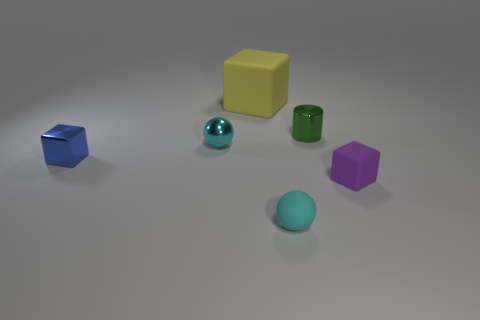What number of small purple blocks are behind the cube that is on the left side of the yellow thing?
Ensure brevity in your answer.  0. Is the number of spheres behind the small blue thing less than the number of blue things?
Your response must be concise. No. Is there a purple rubber object to the left of the small cube to the right of the ball in front of the tiny blue cube?
Offer a very short reply. No. Does the tiny green cylinder have the same material as the sphere on the left side of the big yellow matte cube?
Give a very brief answer. Yes. What is the color of the cylinder behind the purple rubber cube that is on the right side of the big yellow matte object?
Your answer should be very brief. Green. Is there a tiny rubber cube that has the same color as the metallic block?
Your answer should be very brief. No. How big is the matte block that is right of the cyan sphere that is in front of the tiny shiny object that is in front of the tiny cyan metal thing?
Your answer should be compact. Small. Is the shape of the big rubber thing the same as the cyan thing that is on the left side of the large yellow matte thing?
Your answer should be very brief. No. How many other things are there of the same size as the yellow matte cube?
Your answer should be compact. 0. What size is the cyan object that is in front of the blue cube?
Provide a succinct answer. Small. 